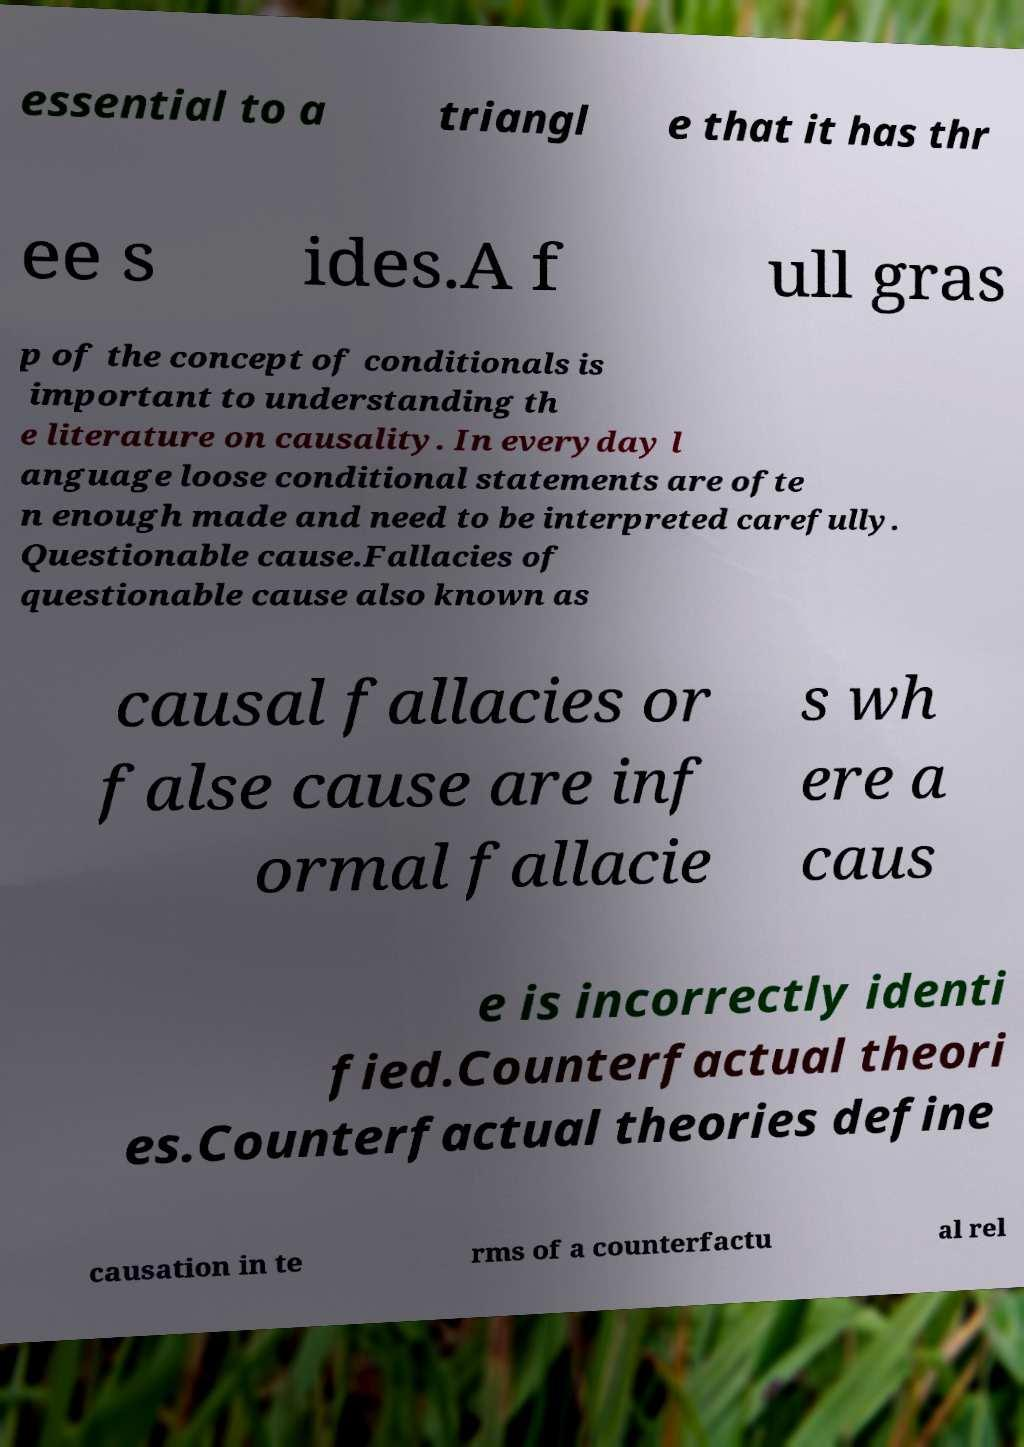There's text embedded in this image that I need extracted. Can you transcribe it verbatim? essential to a triangl e that it has thr ee s ides.A f ull gras p of the concept of conditionals is important to understanding th e literature on causality. In everyday l anguage loose conditional statements are ofte n enough made and need to be interpreted carefully. Questionable cause.Fallacies of questionable cause also known as causal fallacies or false cause are inf ormal fallacie s wh ere a caus e is incorrectly identi fied.Counterfactual theori es.Counterfactual theories define causation in te rms of a counterfactu al rel 